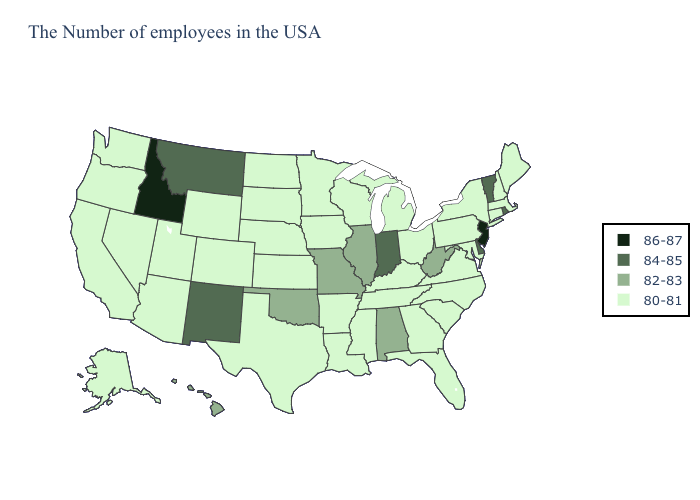What is the value of Maine?
Answer briefly. 80-81. What is the highest value in states that border South Carolina?
Answer briefly. 80-81. Name the states that have a value in the range 80-81?
Quick response, please. Maine, Massachusetts, New Hampshire, Connecticut, New York, Maryland, Pennsylvania, Virginia, North Carolina, South Carolina, Ohio, Florida, Georgia, Michigan, Kentucky, Tennessee, Wisconsin, Mississippi, Louisiana, Arkansas, Minnesota, Iowa, Kansas, Nebraska, Texas, South Dakota, North Dakota, Wyoming, Colorado, Utah, Arizona, Nevada, California, Washington, Oregon, Alaska. Name the states that have a value in the range 86-87?
Quick response, please. New Jersey, Idaho. What is the lowest value in states that border Texas?
Quick response, please. 80-81. Among the states that border Indiana , which have the lowest value?
Concise answer only. Ohio, Michigan, Kentucky. What is the lowest value in states that border Arizona?
Keep it brief. 80-81. Does New Mexico have the lowest value in the USA?
Give a very brief answer. No. Name the states that have a value in the range 84-85?
Short answer required. Rhode Island, Vermont, Delaware, Indiana, New Mexico, Montana. Name the states that have a value in the range 80-81?
Give a very brief answer. Maine, Massachusetts, New Hampshire, Connecticut, New York, Maryland, Pennsylvania, Virginia, North Carolina, South Carolina, Ohio, Florida, Georgia, Michigan, Kentucky, Tennessee, Wisconsin, Mississippi, Louisiana, Arkansas, Minnesota, Iowa, Kansas, Nebraska, Texas, South Dakota, North Dakota, Wyoming, Colorado, Utah, Arizona, Nevada, California, Washington, Oregon, Alaska. What is the lowest value in the Northeast?
Short answer required. 80-81. Name the states that have a value in the range 82-83?
Keep it brief. West Virginia, Alabama, Illinois, Missouri, Oklahoma, Hawaii. What is the value of Nevada?
Be succinct. 80-81. What is the lowest value in the USA?
Concise answer only. 80-81. What is the value of New Hampshire?
Concise answer only. 80-81. 